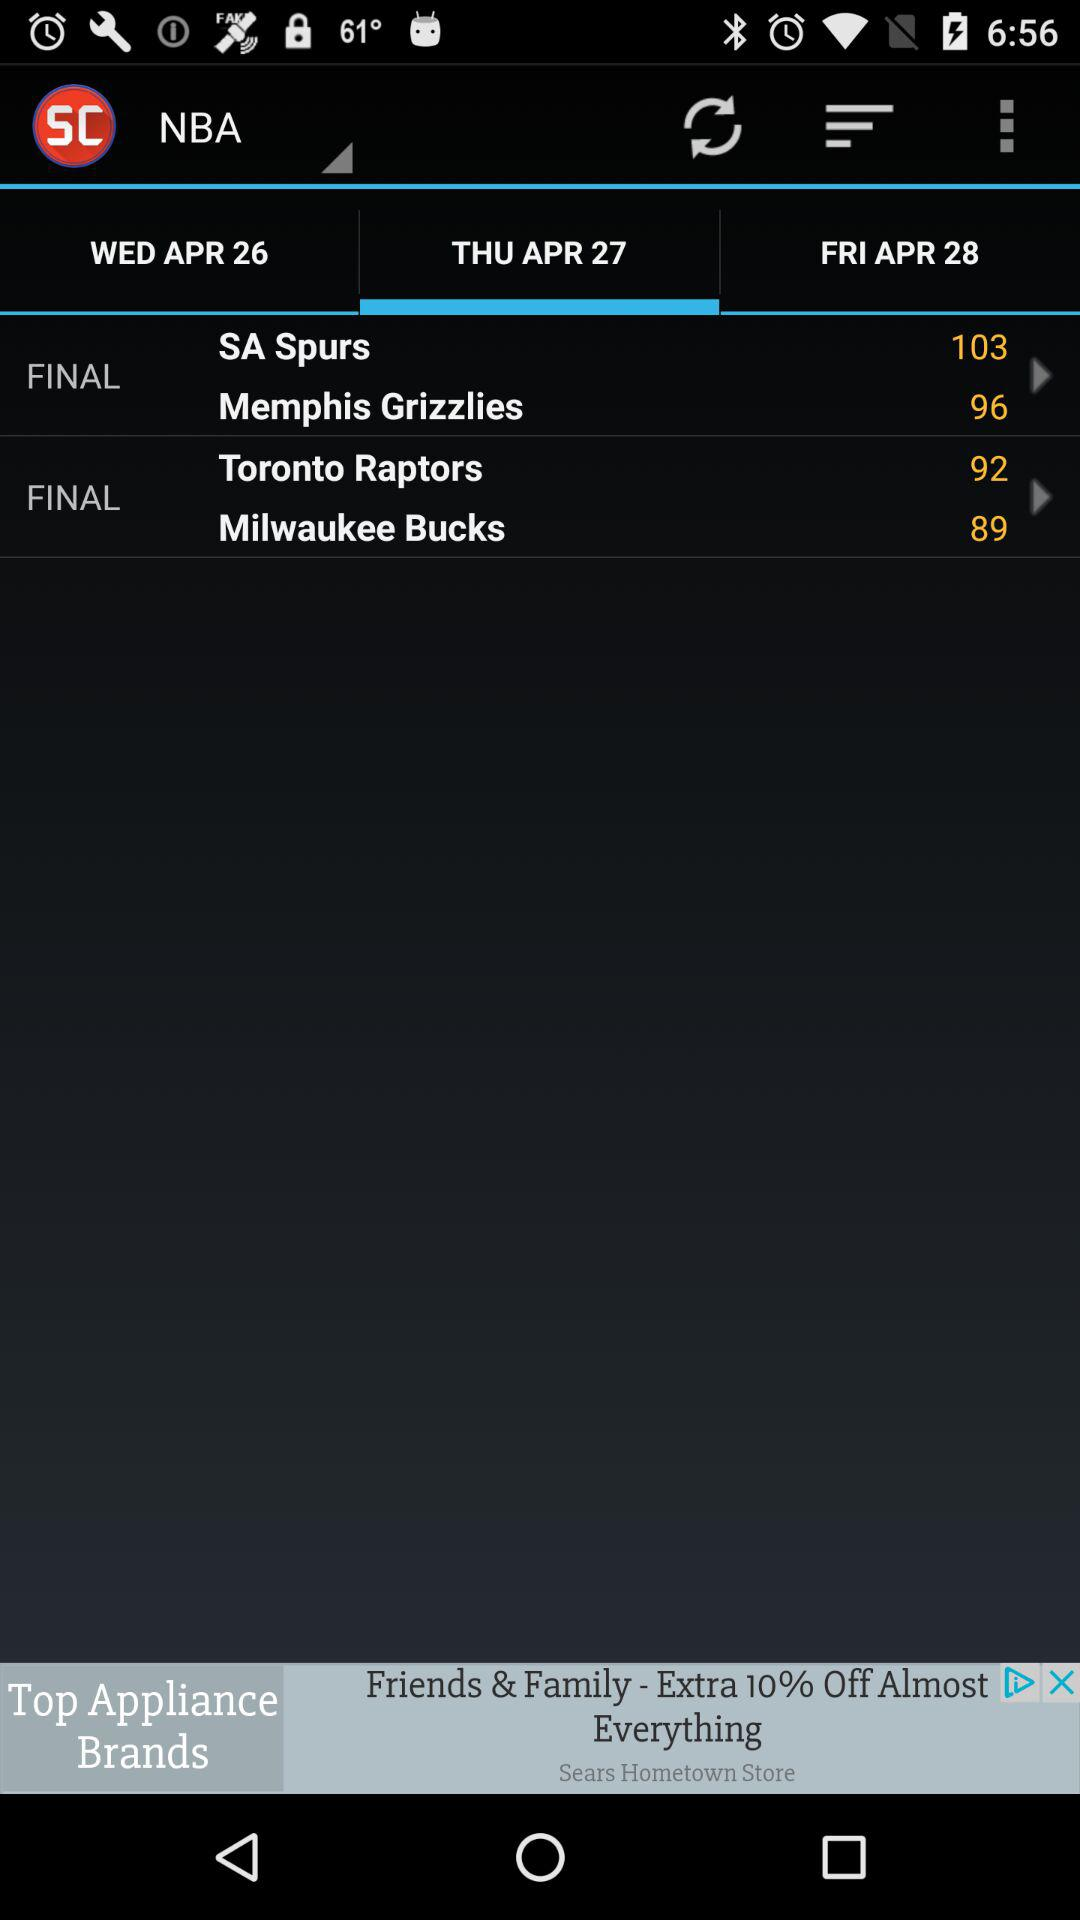Which team has 103 points? The team which has 103 points is "SA Spurs". 